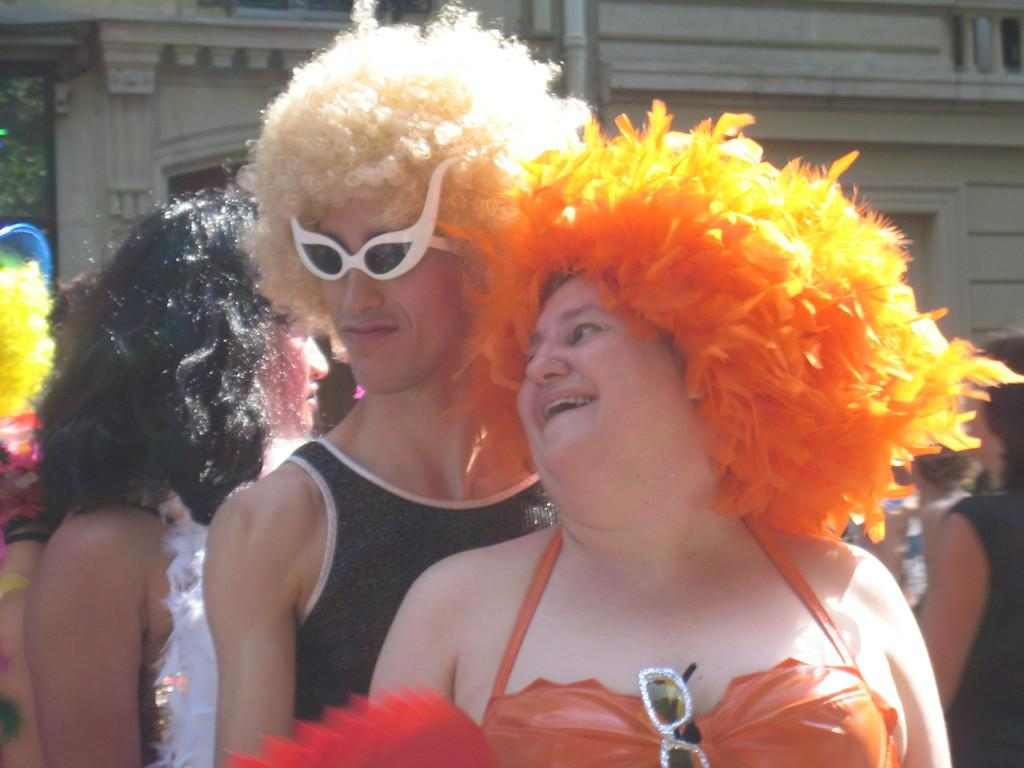How many people are in the image? There is a group of people in the image. What are the people doing in the image? The people are standing. What are the people wearing in the image? The people are wearing costumes. What can be seen in the background of the image? There is a building in the background of the image. How many tickets did the bear purchase for the bee's event in the image? There is no bear or bee present in the image, and therefore no such event or ticket purchase can be observed. 